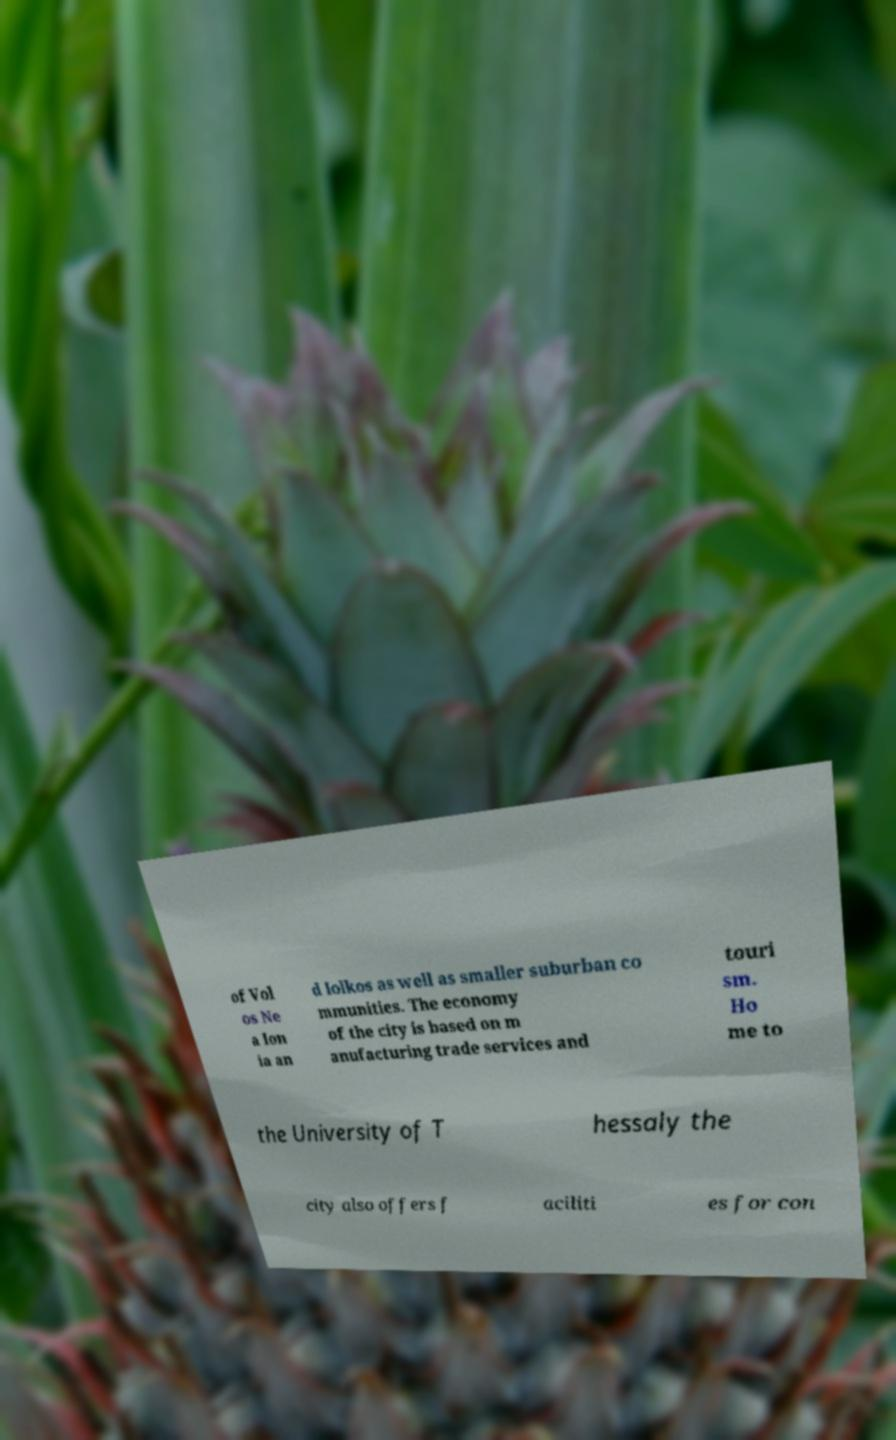For documentation purposes, I need the text within this image transcribed. Could you provide that? of Vol os Ne a Ion ia an d Iolkos as well as smaller suburban co mmunities. The economy of the city is based on m anufacturing trade services and touri sm. Ho me to the University of T hessaly the city also offers f aciliti es for con 